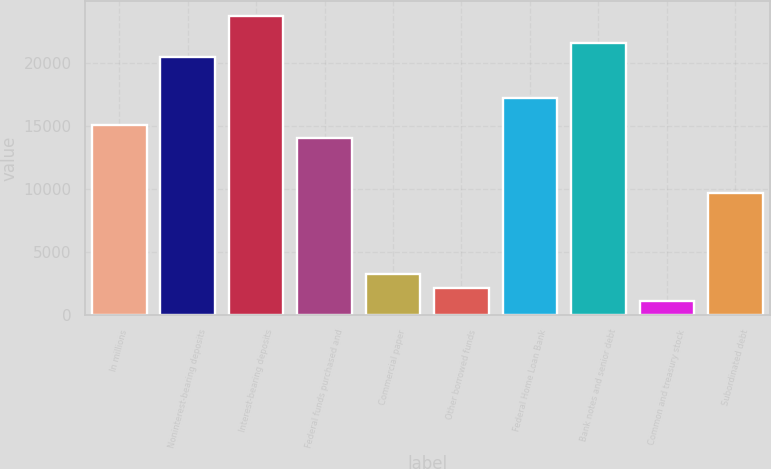<chart> <loc_0><loc_0><loc_500><loc_500><bar_chart><fcel>In millions<fcel>Noninterest-bearing deposits<fcel>Interest-bearing deposits<fcel>Federal funds purchased and<fcel>Commercial paper<fcel>Other borrowed funds<fcel>Federal Home Loan Bank<fcel>Bank notes and senior debt<fcel>Common and treasury stock<fcel>Subordinated debt<nl><fcel>15125.2<fcel>20516.7<fcel>23751.6<fcel>14046.9<fcel>3263.9<fcel>2185.6<fcel>17281.8<fcel>21595<fcel>1107.3<fcel>9733.7<nl></chart> 